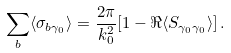Convert formula to latex. <formula><loc_0><loc_0><loc_500><loc_500>\sum _ { b } \langle \sigma _ { b \gamma _ { 0 } } \rangle = \frac { 2 \pi } { k ^ { 2 } _ { 0 } } [ 1 - \Re \langle S _ { \gamma _ { 0 } \gamma _ { 0 } } \rangle ] \, .</formula> 